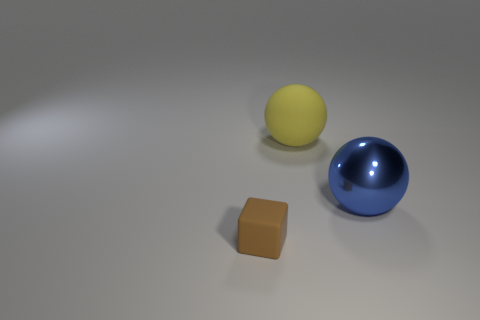How many things are in front of the yellow sphere and to the left of the metallic thing?
Ensure brevity in your answer.  1. Are there any other things that are made of the same material as the blue object?
Offer a terse response. No. The yellow matte thing that is the same shape as the blue metal object is what size?
Ensure brevity in your answer.  Large. Are there any small cubes right of the blue shiny thing?
Provide a succinct answer. No. Is the number of matte blocks that are left of the brown block the same as the number of tiny gray blocks?
Keep it short and to the point. Yes. There is a big sphere to the right of the ball that is to the left of the big blue shiny thing; is there a thing behind it?
Make the answer very short. Yes. What is the material of the large blue sphere?
Offer a terse response. Metal. How many other things are the same shape as the blue metal thing?
Make the answer very short. 1. Do the big blue shiny thing and the yellow matte thing have the same shape?
Offer a terse response. Yes. What number of things are either matte objects behind the brown matte cube or rubber things that are behind the brown rubber thing?
Offer a terse response. 1. 